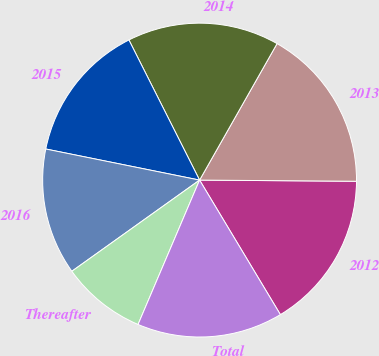Convert chart to OTSL. <chart><loc_0><loc_0><loc_500><loc_500><pie_chart><fcel>2012<fcel>2013<fcel>2014<fcel>2015<fcel>2016<fcel>Thereafter<fcel>Total<nl><fcel>16.27%<fcel>16.9%<fcel>15.65%<fcel>14.39%<fcel>13.04%<fcel>8.72%<fcel>15.02%<nl></chart> 